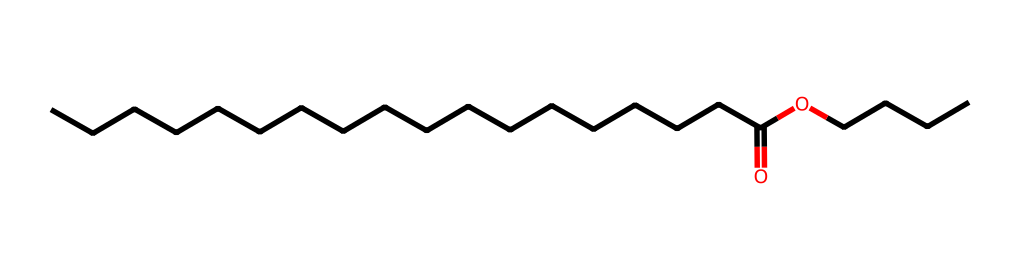What is the total number of carbon atoms in butyl stearate? The chemical structure shows a long carbon chain in both the butyl and stearate parts of the molecule. The butyl group contributes 4 carbon atoms, and the stearate part, which has 18 carbon atoms, brings the total to 22.
Answer: 22 How many oxygen atoms are present in butyl stearate? In the chemical structure, there are 2 oxygen atoms visible: one is part of the ester functional group (C(=O)O), and the other is connected to the butyl group (CO).
Answer: 2 What type of functional group is present in butyl stearate? The structure displays a carbonyl group (C=O) bonded to an alkoxy group (O-C), which defines it as an ester. This combination is characteristic of esters.
Answer: ester What is the longest carbon chain length in butyl stearate? By analyzing the stearate part of the molecule, which consists of 18 consecutive carbon atoms, we determine the longest carbon chain is in this segment. Thus, the length of the longest chain is 18.
Answer: 18 Does butyl stearate have any double bonds in its hydrocarbon chains? In the provided SMILES representation, we observe that the carbon chains consist of single bonds exclusively, as indicated by the lack of any indication of double bonds (like C=C) in the structure.
Answer: no How many hydrogen atoms are likely bonded to the main carbon chains of butyl stearate? Each carbon in the butyl part has 3 hydrogens (3 carbons) and all but the terminal carbons in the stearate chain typically bond with 2 hydrogens, with the terminal carbon having 3. Thus, calculating gives us 42 hydrogen atoms for the entire structure considering the ester formation.
Answer: 42 